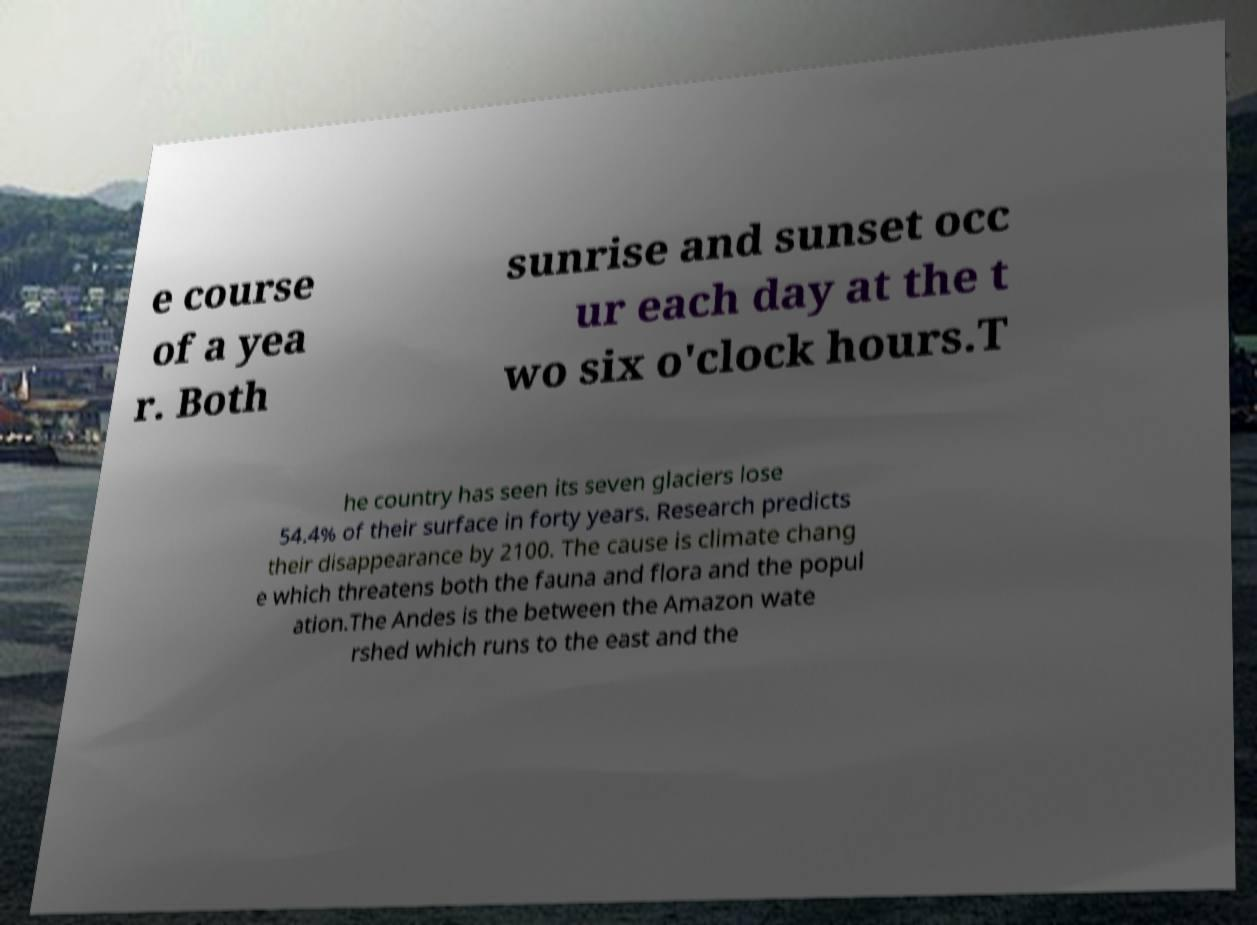There's text embedded in this image that I need extracted. Can you transcribe it verbatim? e course of a yea r. Both sunrise and sunset occ ur each day at the t wo six o'clock hours.T he country has seen its seven glaciers lose 54.4% of their surface in forty years. Research predicts their disappearance by 2100. The cause is climate chang e which threatens both the fauna and flora and the popul ation.The Andes is the between the Amazon wate rshed which runs to the east and the 